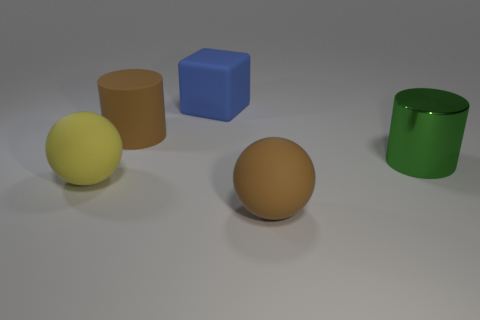Is the material of the big cube the same as the sphere behind the large brown sphere? Yes, the big blue cube and the smaller sphere positioned behind the large brown sphere seem to share a similar smooth and shiny texture, which suggests that they could be made of the same or similar materials, typically indicative of plastic or polished metals in a rendered image like this. 